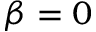Convert formula to latex. <formula><loc_0><loc_0><loc_500><loc_500>\beta = 0</formula> 